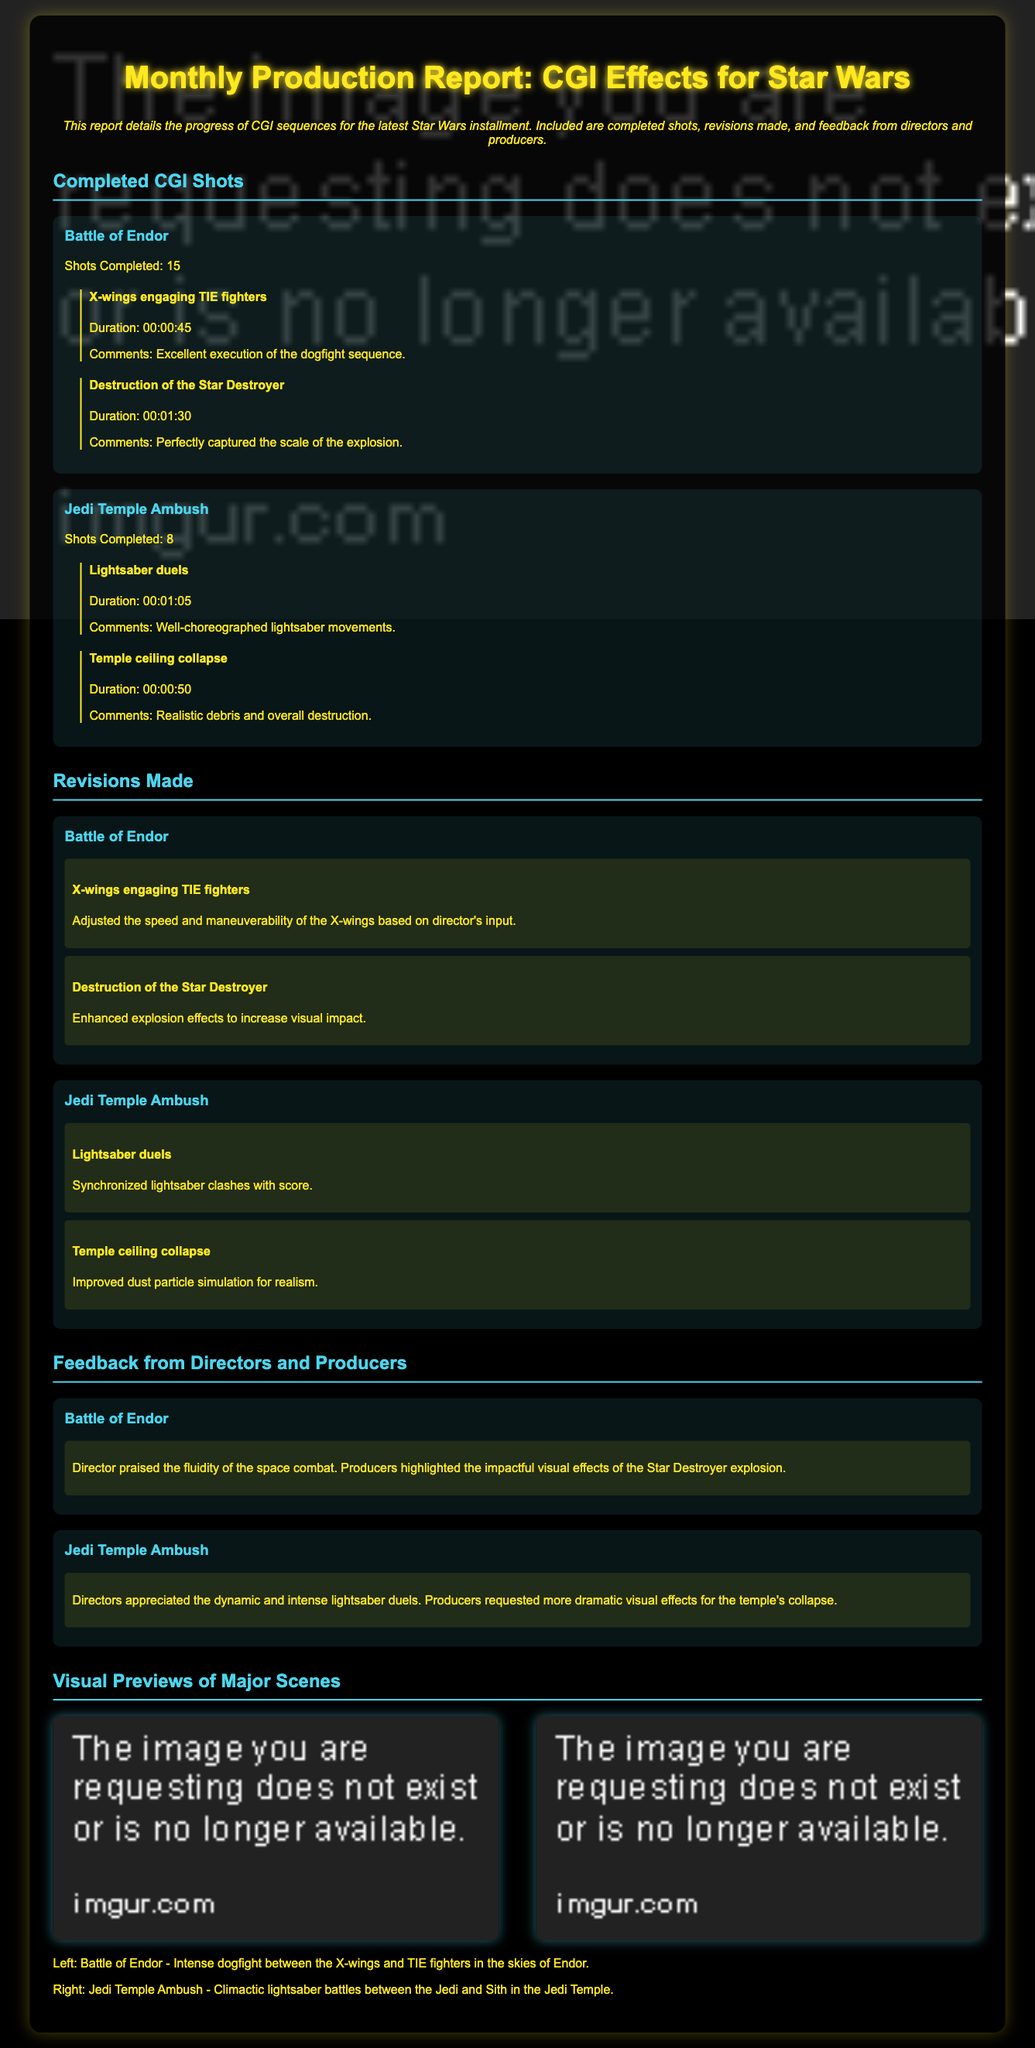what is the title of the report? The title of the report is indicated at the top of the document.
Answer: Monthly Production Report: CGI Effects for Star Wars how many shots were completed for the Battle of Endor? The document lists the number of completed shots under each CGI sequence.
Answer: 15 what feedback did the director give regarding the Battle of Endor? The feedback section describes the directors' and producers' comments on specific sequences.
Answer: praised the fluidity of the space combat what adjustments were made to the X-wings engaging TIE fighters? The revisions section outlines changes made to the CGI shots based on feedback.
Answer: Adjusted the speed and maneuverability which key shot had a duration of 1 minute and 30 seconds? The document specifies the duration of each key shot under the completed CGI shots.
Answer: Destruction of the Star Destroyer how many key shots were completed for the Jedi Temple Ambush? The completed CGI shots section details the number of key shots for each sequence.
Answer: 8 what did producers request for the temple's collapse? The feedback section indicates specific requests from producers for further enhancements.
Answer: more dramatic visual effects what is shown in the left visual preview? The document describes the content of each visual preview displayed.
Answer: Battle of Endor - Intense dogfight between the X-wings and TIE fighters in the skies of Endor 